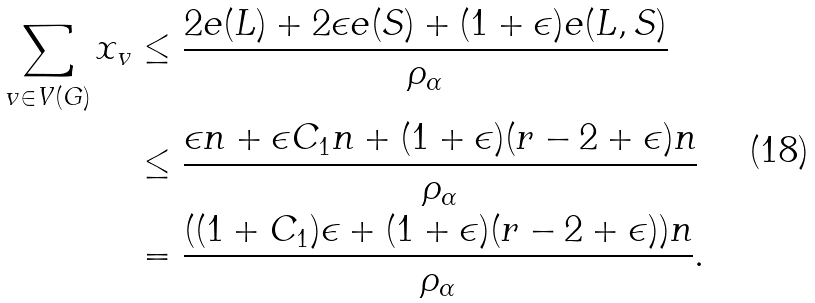Convert formula to latex. <formula><loc_0><loc_0><loc_500><loc_500>\sum _ { v \in V ( G ) } x _ { v } & \leq \frac { 2 e ( L ) + 2 \epsilon e ( S ) + ( 1 + \epsilon ) e ( L , S ) } { \rho _ { \alpha } } \\ & \leq \frac { \epsilon n + \epsilon C _ { 1 } n + ( 1 + \epsilon ) ( r - 2 + \epsilon ) n } { \rho _ { \alpha } } \\ & = \frac { ( ( 1 + C _ { 1 } ) \epsilon + ( 1 + \epsilon ) ( r - 2 + \epsilon ) ) n } { \rho _ { \alpha } } .</formula> 